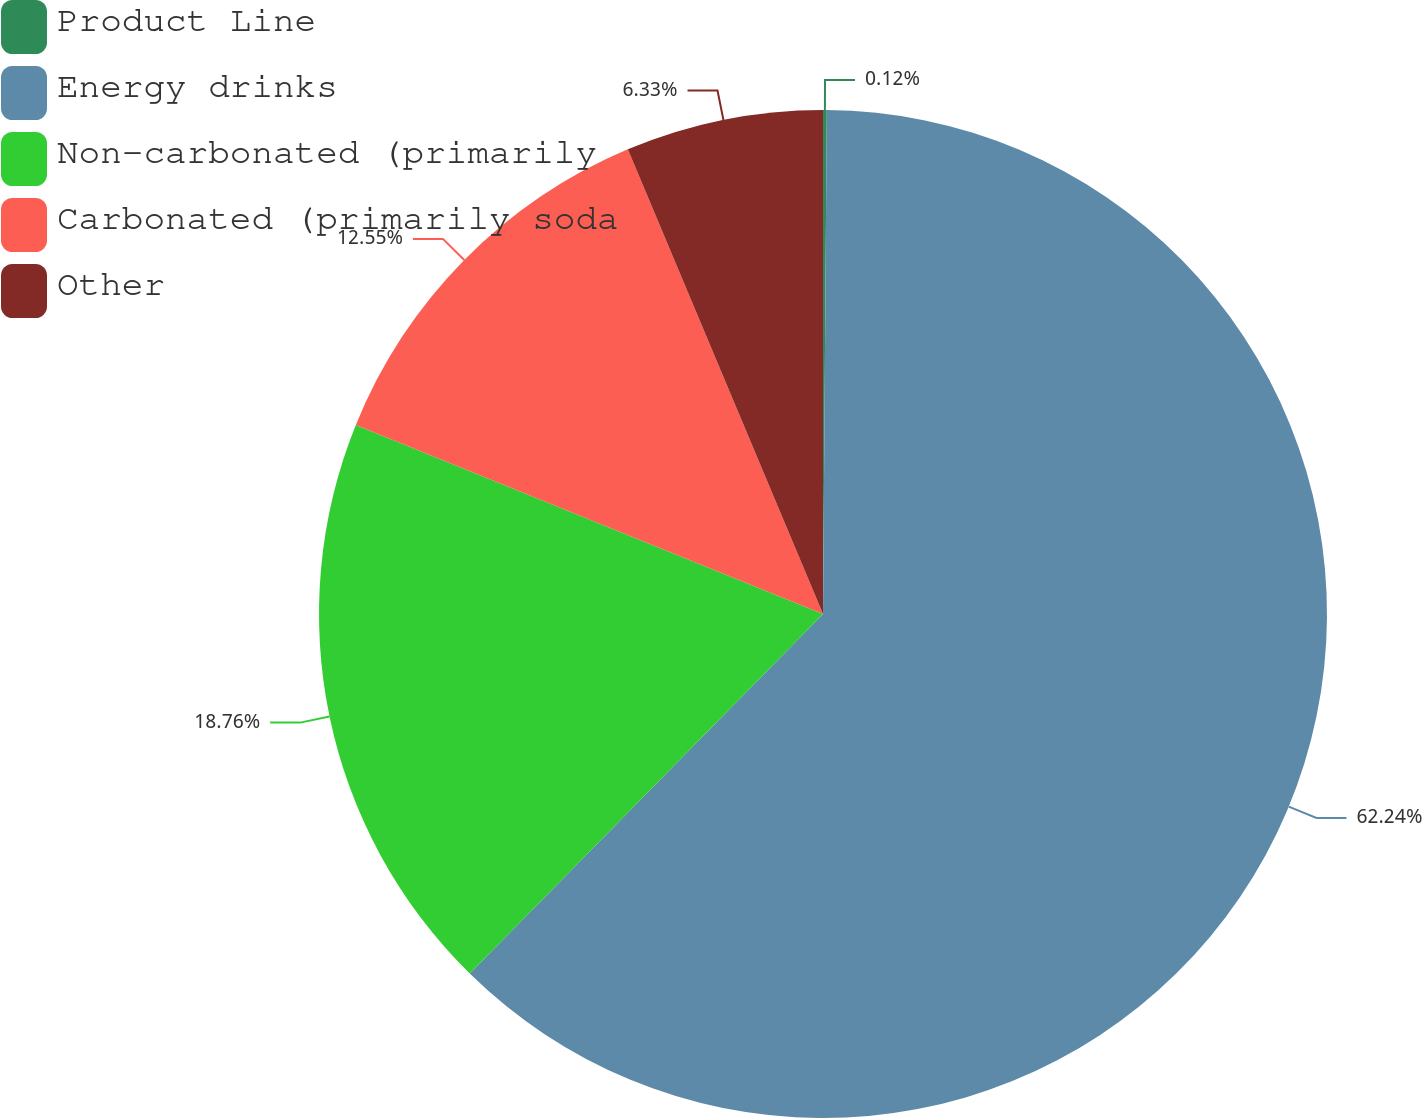Convert chart. <chart><loc_0><loc_0><loc_500><loc_500><pie_chart><fcel>Product Line<fcel>Energy drinks<fcel>Non-carbonated (primarily<fcel>Carbonated (primarily soda<fcel>Other<nl><fcel>0.12%<fcel>62.24%<fcel>18.76%<fcel>12.55%<fcel>6.33%<nl></chart> 